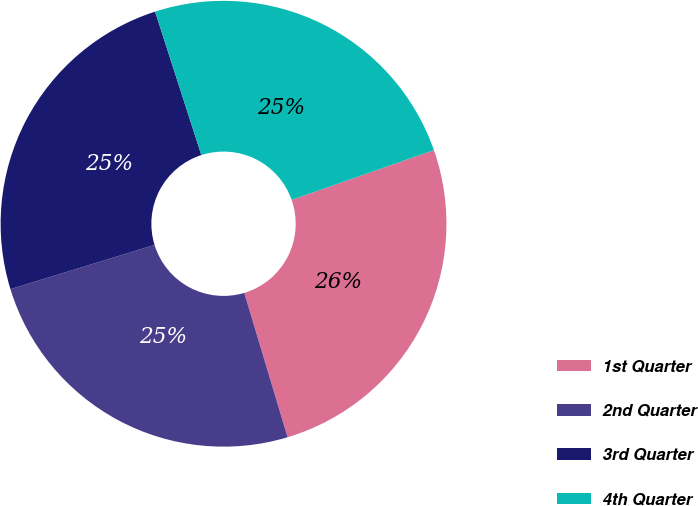Convert chart. <chart><loc_0><loc_0><loc_500><loc_500><pie_chart><fcel>1st Quarter<fcel>2nd Quarter<fcel>3rd Quarter<fcel>4th Quarter<nl><fcel>25.72%<fcel>24.9%<fcel>24.77%<fcel>24.61%<nl></chart> 